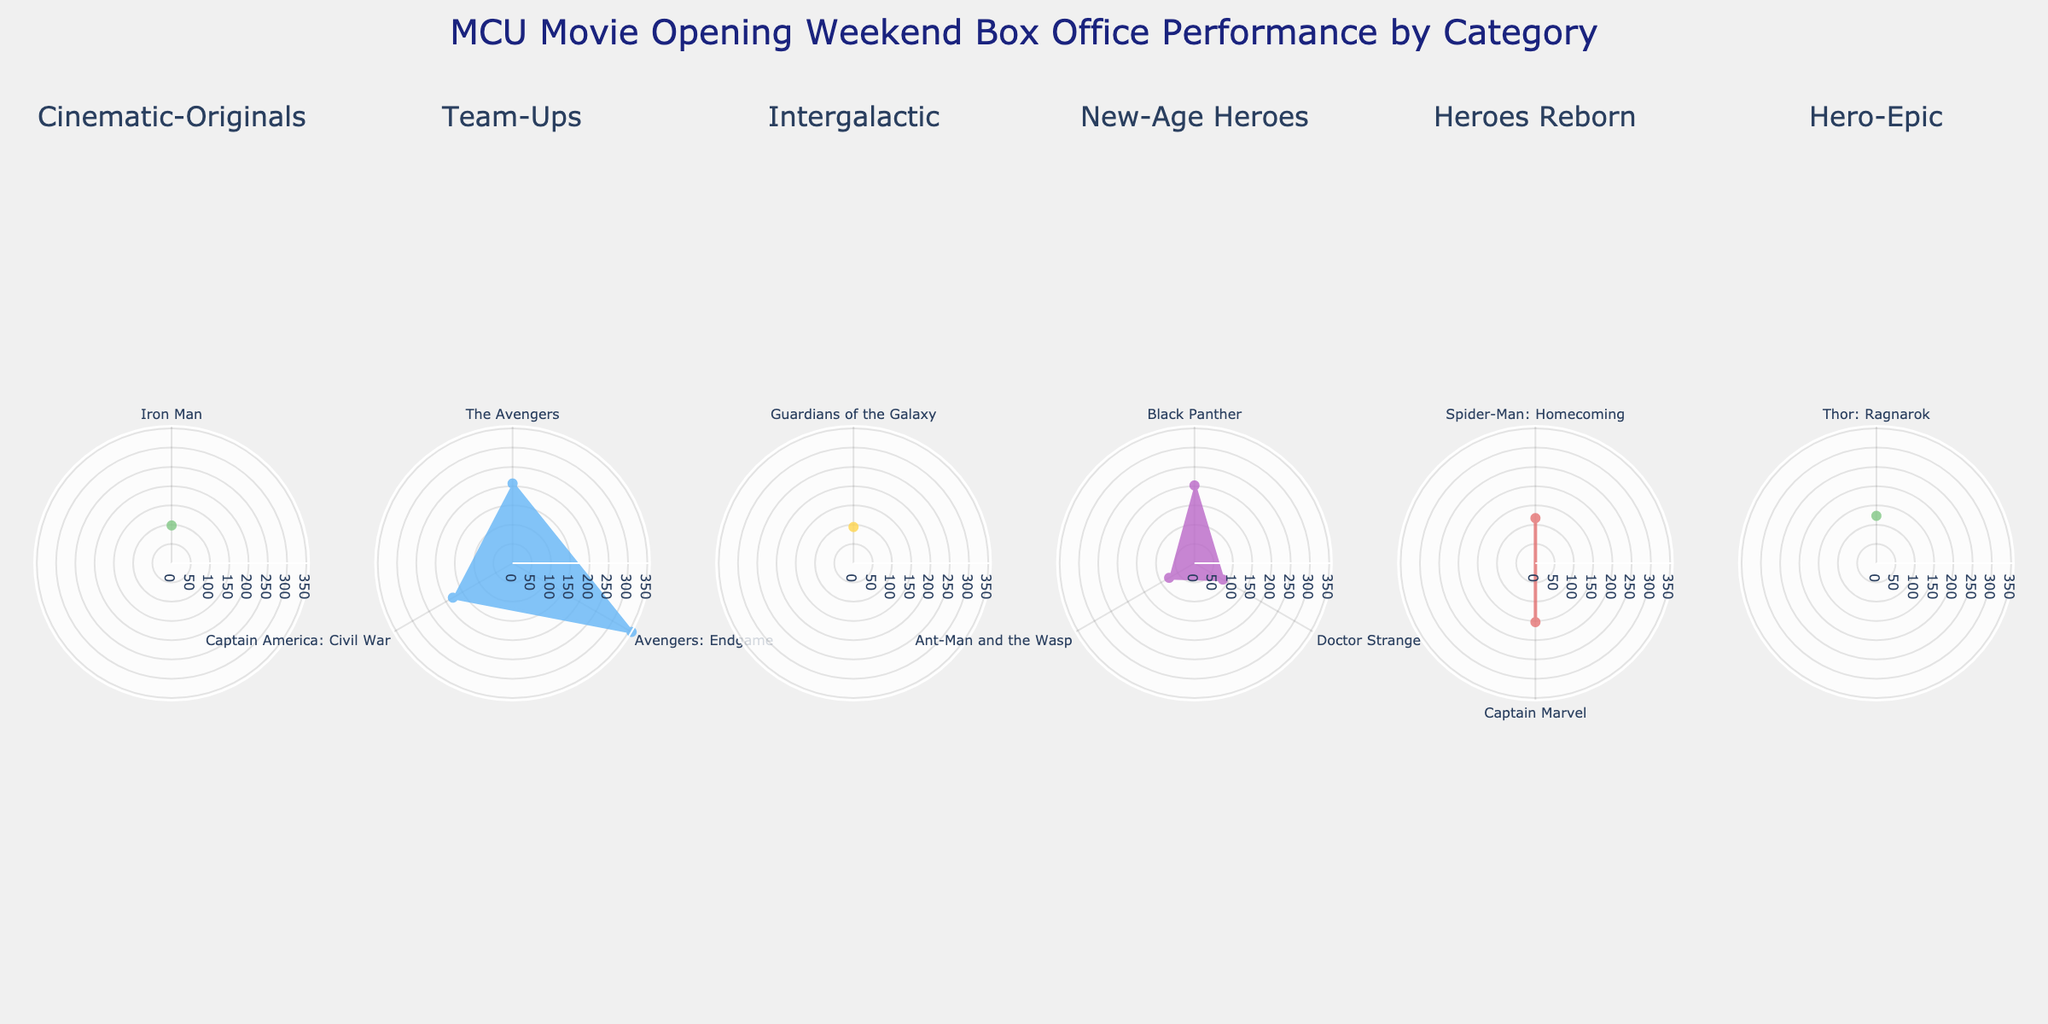What is the title of the plot? The title of the plot is displayed prominently at the top and reads "MCU Movie Opening Weekend Box Office Performance by Category."
Answer: MCU Movie Opening Weekend Box Office Performance by Category How many categories of movies are there in the plot? The plot contains one subplot for each unique movie category. By counting the subplot titles, you can determine there are five categories: Cinematic-Originals, Team-Ups, Intergalactic, New-Age Heroes, and Heroes Reborn.
Answer: Five Which movie in the "Team-Ups" category had the highest opening weekend box office performance? In the "Team-Ups" subplot, the movie corresponding to the highest radial distance on the polar chart indicates the highest opening weekend box office performance. This movie is "Avengers: Endgame."
Answer: Avengers: Endgame How does the opening weekend box office performance of "Doctor Strange" compare to "Black Panther"? "Doctor Strange" is in the "New-Age Heroes" category and has a lower radial distance compared to "Black Panther" in the same subplot. The radial distance signifies the box office performance, so "Doctor Strange" had a lower opening weekend box office performance than "Black Panther."
Answer: Lower What is the range of the radial axis in the plots? The radial axis range for the plots is given in each subplot and it spans from 0 to the maximum value indicated. Here, the maximum value is the highest opening weekend box office performance, which is 357 million dollars for "Avengers: Endgame."
Answer: 0 to 357 million dollars Which movie in the "Heroes Reborn" category performed better on its opening weekend: "Spider-Man: Homecoming" or "Captain Marvel"? By comparing the radial distances in the "Heroes Reborn" subplot, "Captain Marvel" has a greater radial distance than "Spider-Man: Homecoming," indicating a higher opening weekend box office performance.
Answer: Captain Marvel What is the average opening weekend box office for the "Team-Ups" category? To find the average, sum the opening weekend box office performances of "The Avengers," "Avengers: Endgame," and "Captain America: Civil War," and divide by the number of movies. The sum is 207 + 357 + 179 = 743, and the average is 743 / 3 = 247.67 million dollars.
Answer: 247.67 million dollars Which category has the least number of movies? Counting the number of points (movies) in each subplot reveals that "Intergalactic" has only one movie, "Guardians of the Galaxy."
Answer: Intergalactic Which movie in the "Hero-Epic" category had highest opening weekend? In the "Hero-Epic" subplot, the only movie is "Thor: Ragnarok." Since it’s the only data point, it has the highest opening weekend box office in that category.
Answer: Thor: Ragnarok 